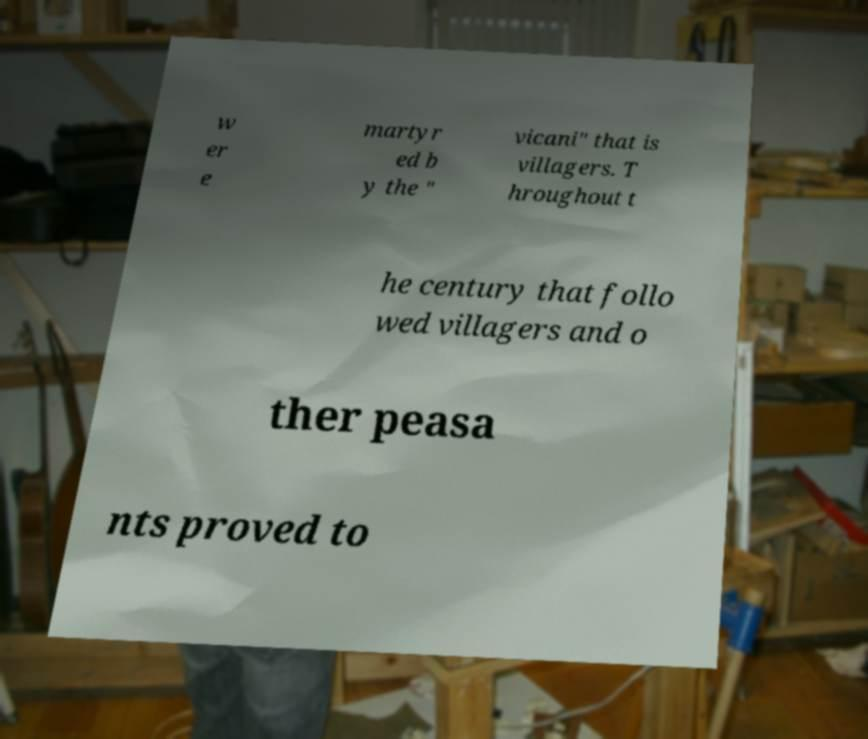Can you read and provide the text displayed in the image?This photo seems to have some interesting text. Can you extract and type it out for me? w er e martyr ed b y the " vicani" that is villagers. T hroughout t he century that follo wed villagers and o ther peasa nts proved to 